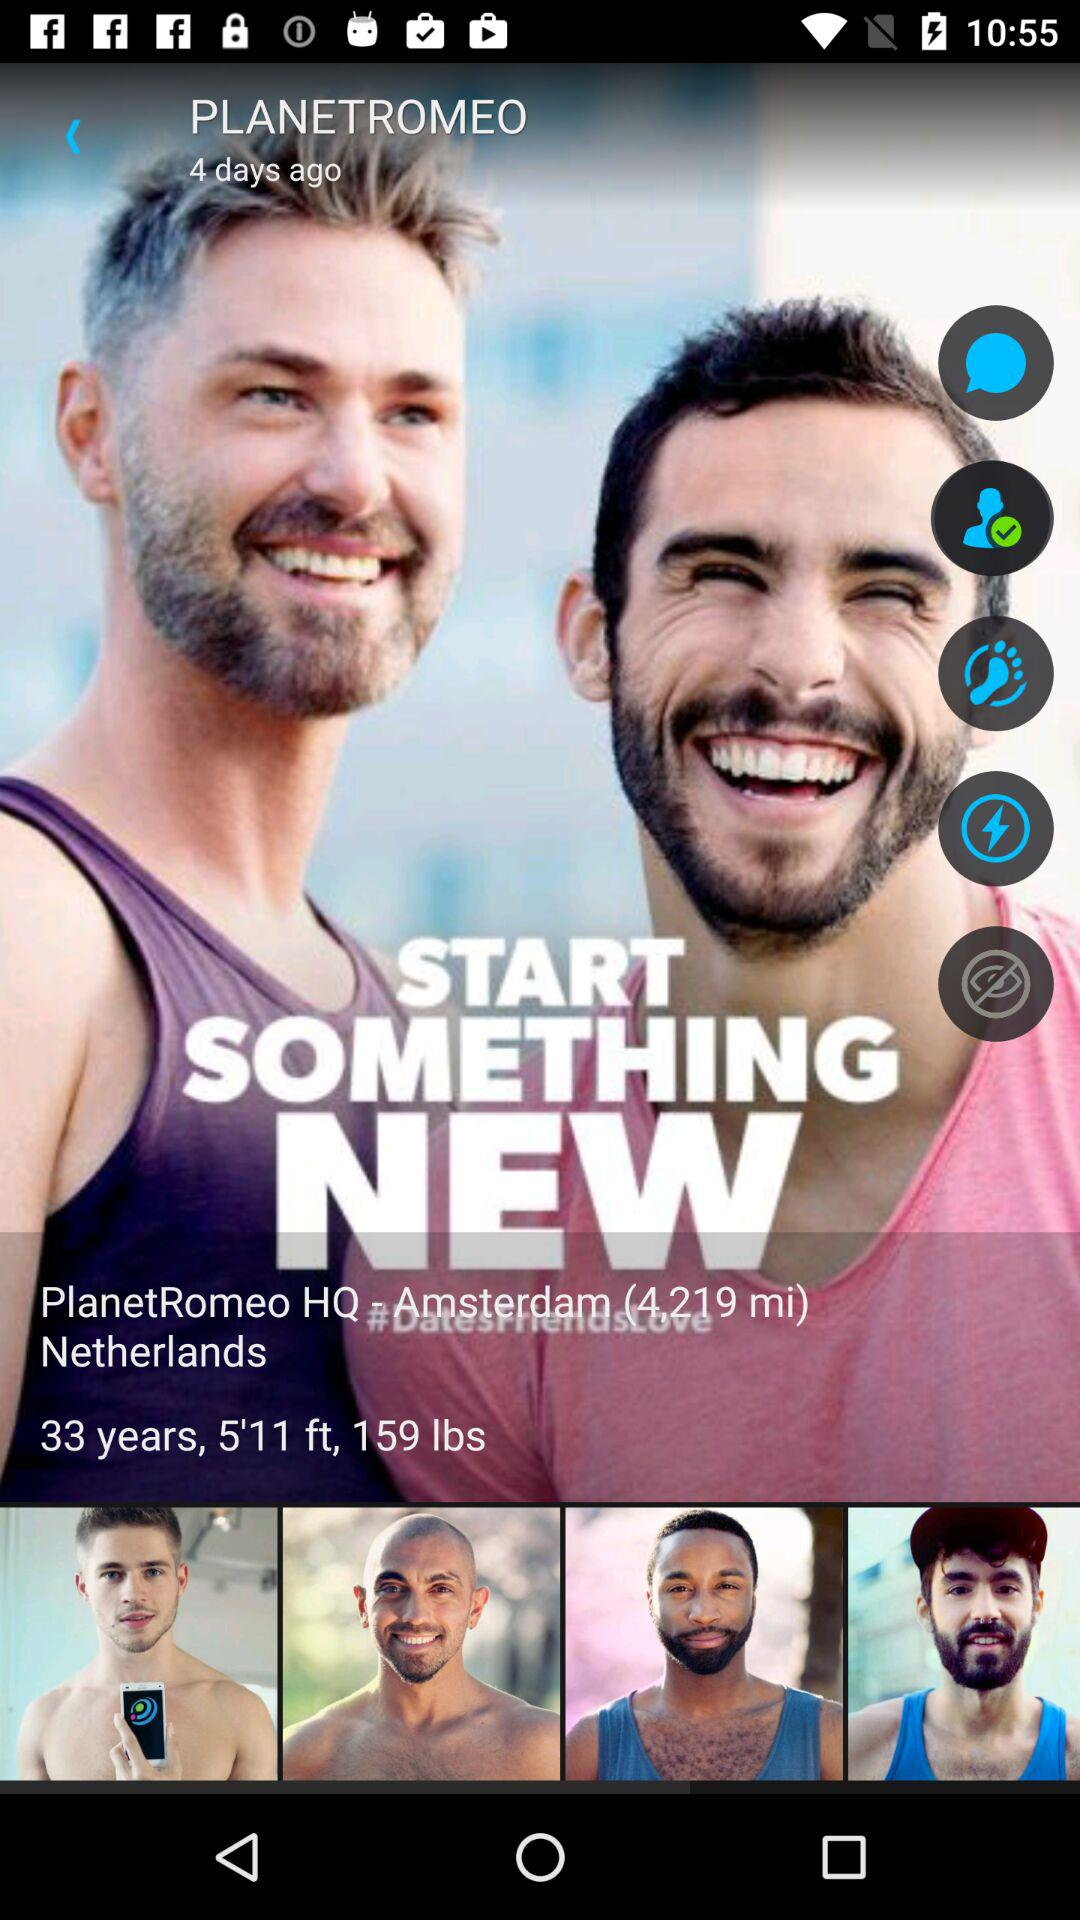What is the height of PlanetRomeo? The height is 5'11 ft. 